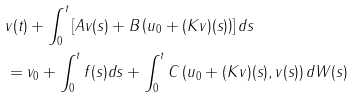<formula> <loc_0><loc_0><loc_500><loc_500>& v ( t ) + \int _ { 0 } ^ { t } \left [ A v ( s ) + B \left ( u _ { 0 } + ( K v ) ( s ) \right ) \right ] d s \\ & = v _ { 0 } + \int _ { 0 } ^ { t } f ( s ) d s + \int _ { 0 } ^ { t } C \left ( u _ { 0 } + ( K v ) ( s ) , v ( s ) \right ) d W ( s )</formula> 